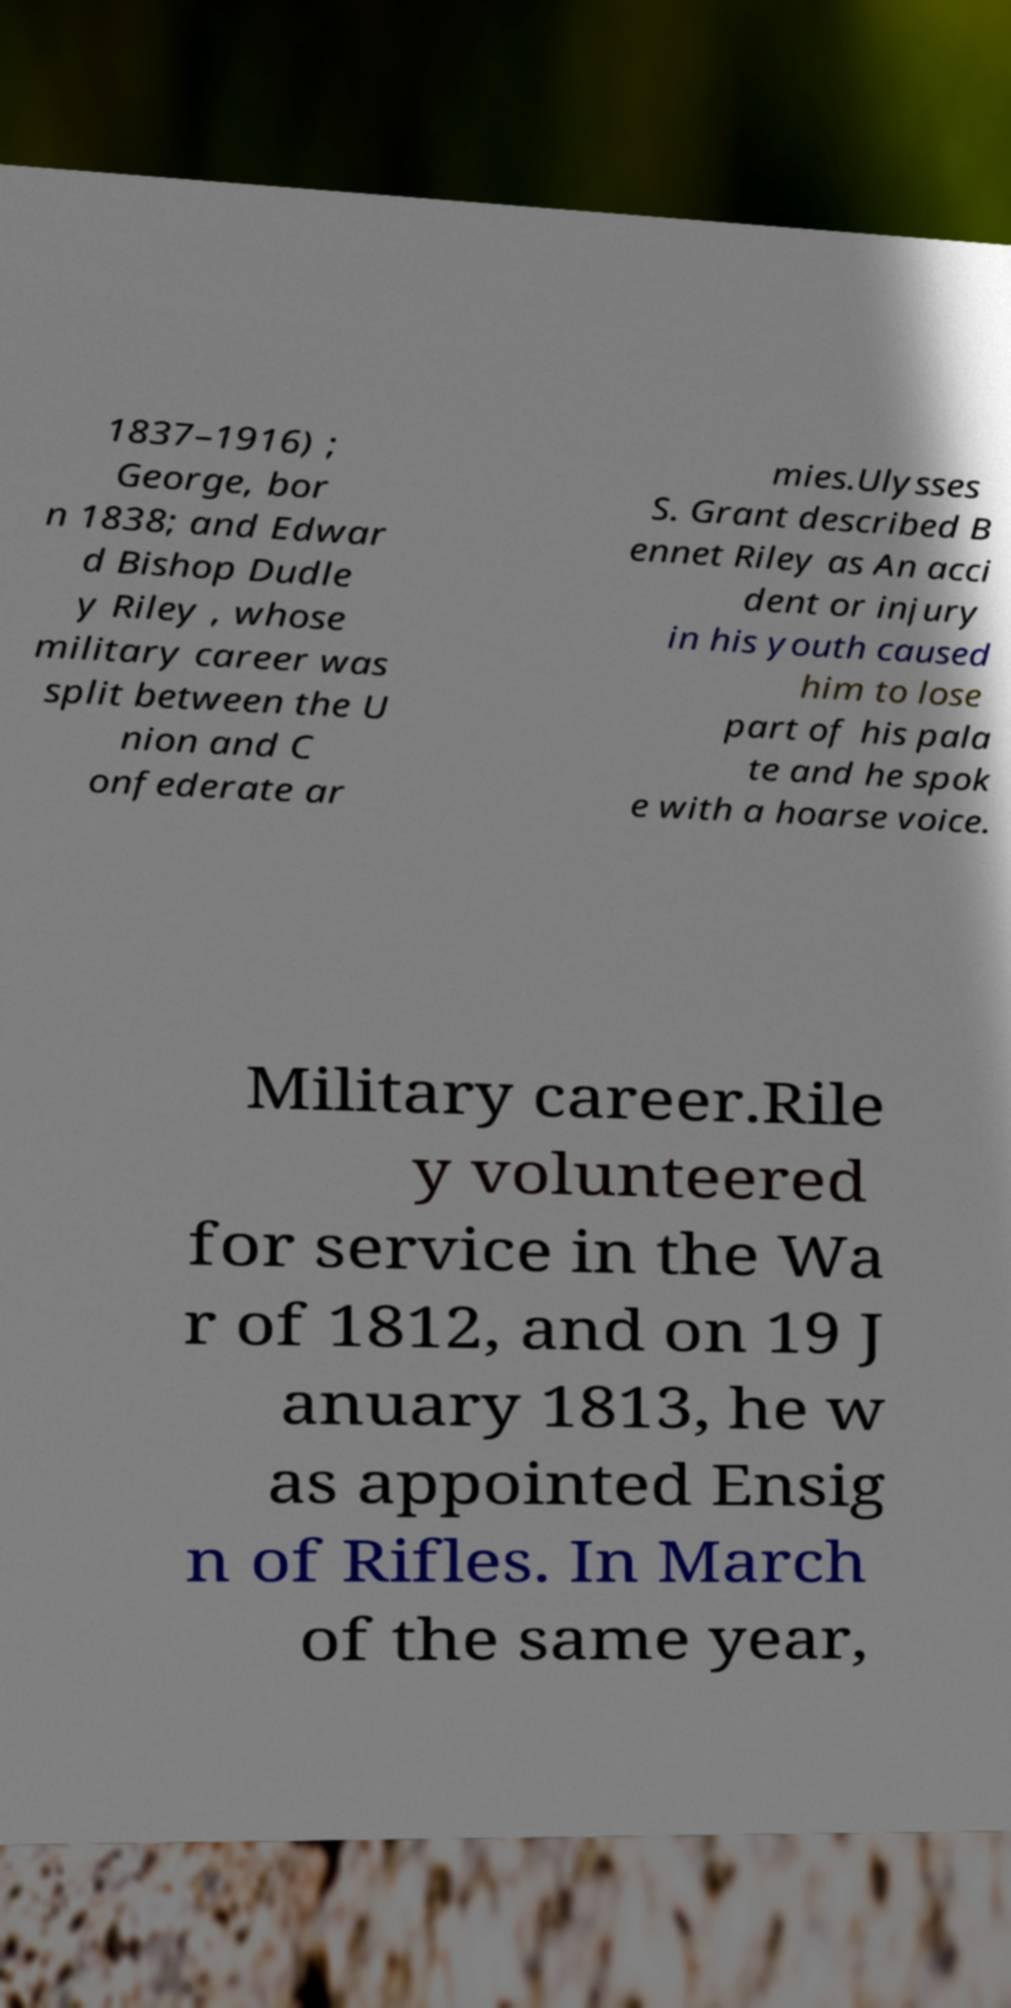There's text embedded in this image that I need extracted. Can you transcribe it verbatim? 1837–1916) ; George, bor n 1838; and Edwar d Bishop Dudle y Riley , whose military career was split between the U nion and C onfederate ar mies.Ulysses S. Grant described B ennet Riley as An acci dent or injury in his youth caused him to lose part of his pala te and he spok e with a hoarse voice. Military career.Rile y volunteered for service in the Wa r of 1812, and on 19 J anuary 1813, he w as appointed Ensig n of Rifles. In March of the same year, 